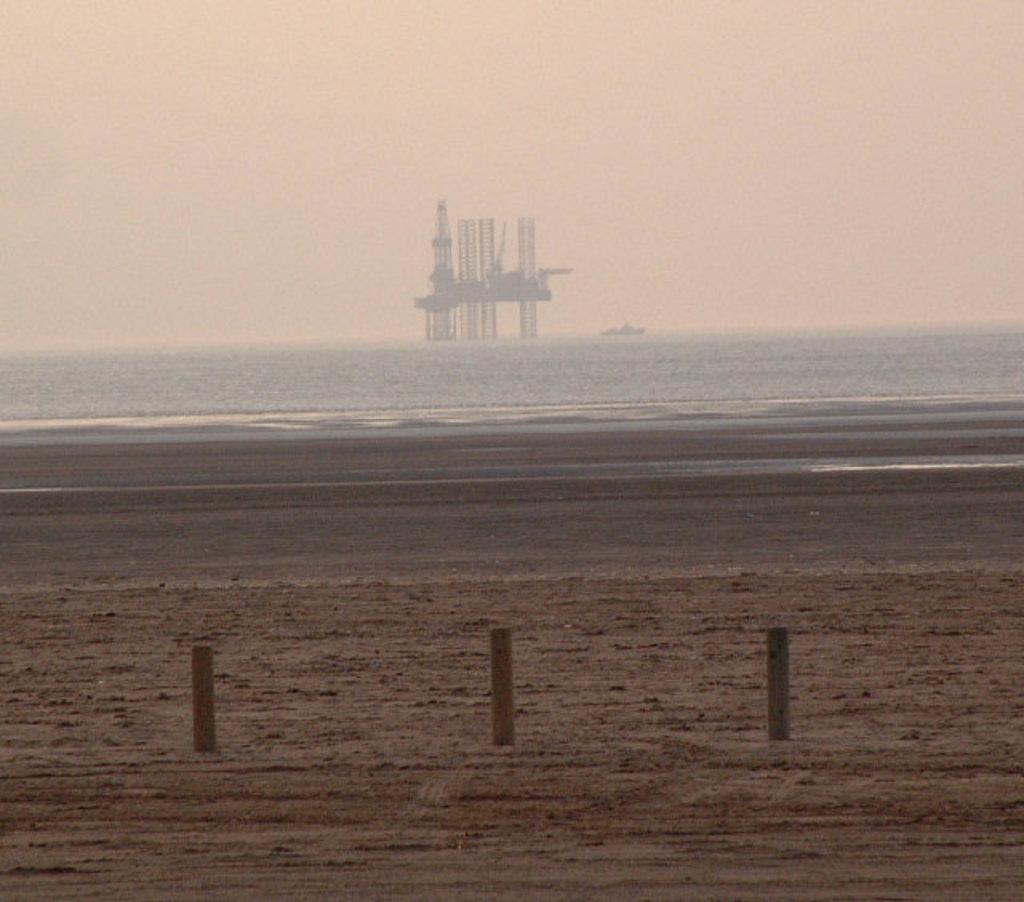Please provide a concise description of this image. In this aimeg, we can see ground and poles. Background we can see water, towers and sky. 